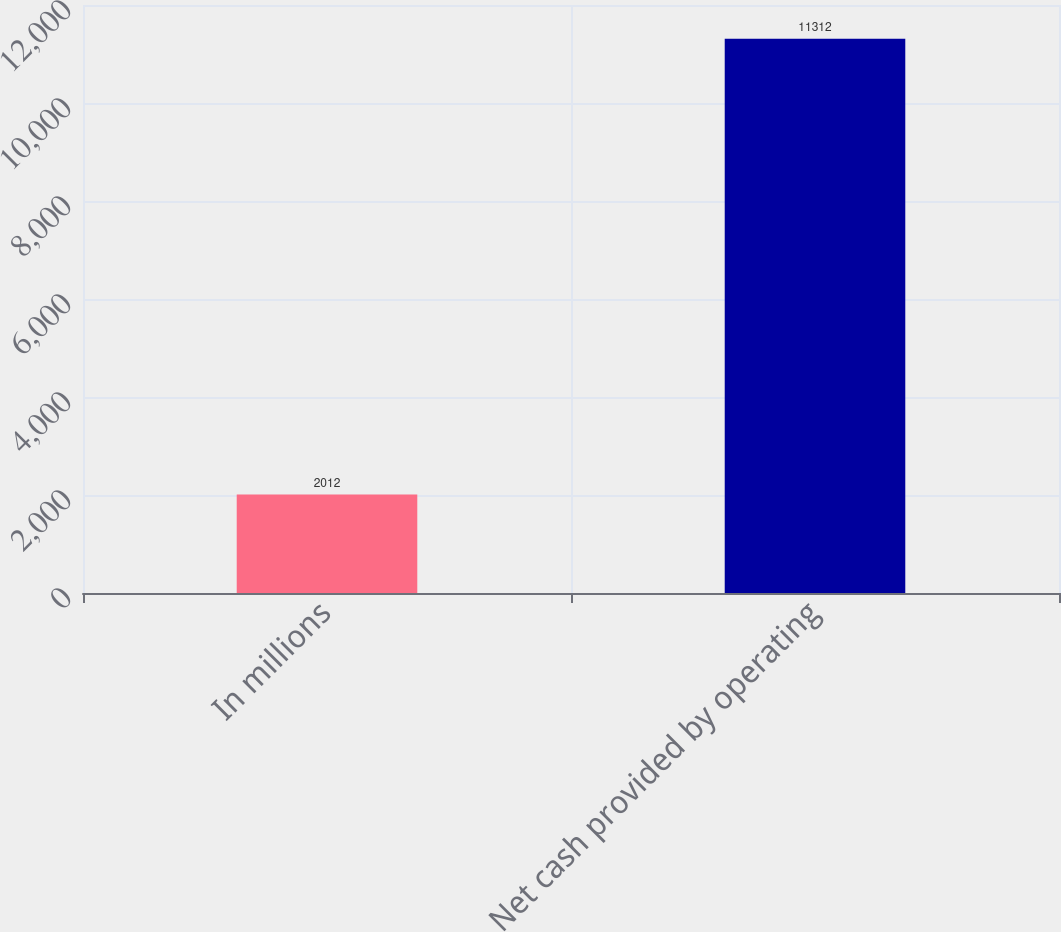Convert chart to OTSL. <chart><loc_0><loc_0><loc_500><loc_500><bar_chart><fcel>In millions<fcel>Net cash provided by operating<nl><fcel>2012<fcel>11312<nl></chart> 